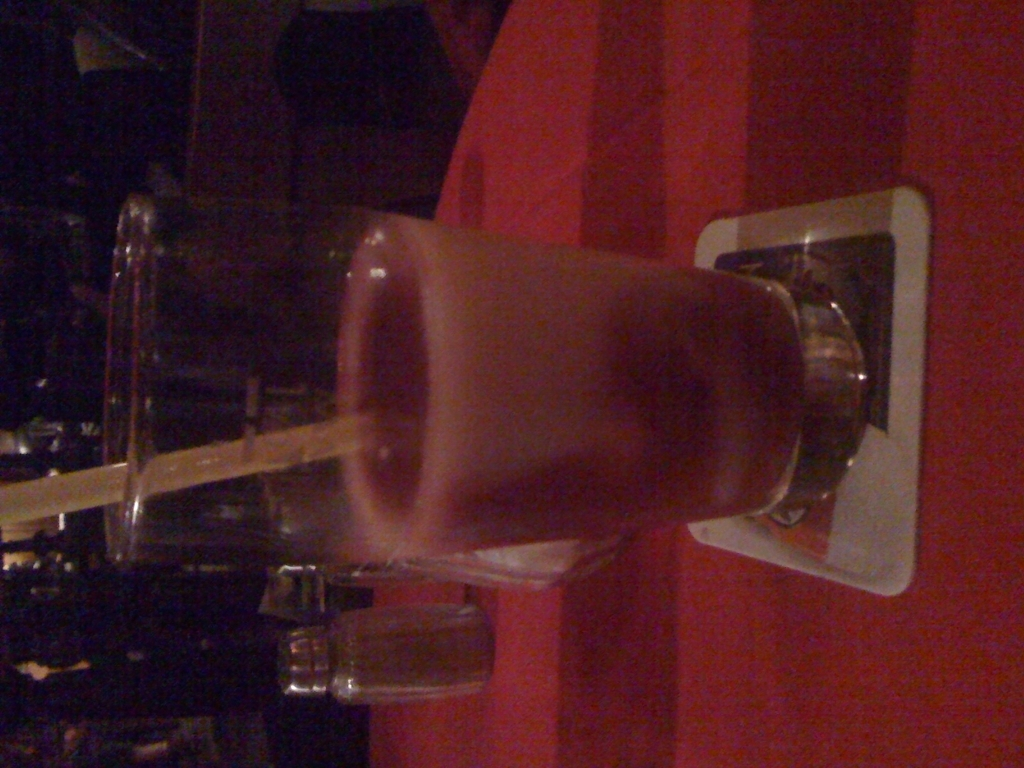Are there any quality issues with this image? Yes, there are several quality issues with the image. The orientation is incorrect as the image is rotated 90 degrees to the left, which might be disorienting for the viewer. Additionally, the lighting appears dim, and the focus is not sharp. These factors could be improved for better visual clarity. 